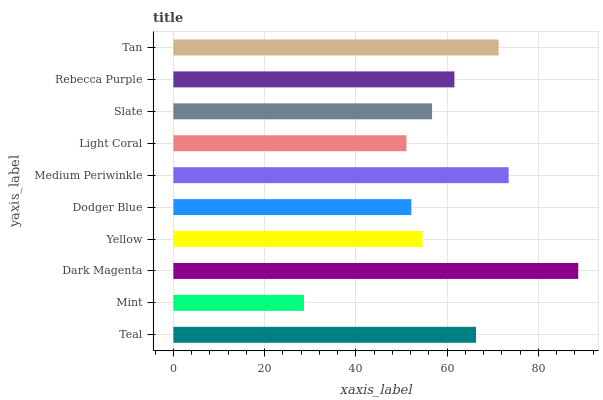Is Mint the minimum?
Answer yes or no. Yes. Is Dark Magenta the maximum?
Answer yes or no. Yes. Is Dark Magenta the minimum?
Answer yes or no. No. Is Mint the maximum?
Answer yes or no. No. Is Dark Magenta greater than Mint?
Answer yes or no. Yes. Is Mint less than Dark Magenta?
Answer yes or no. Yes. Is Mint greater than Dark Magenta?
Answer yes or no. No. Is Dark Magenta less than Mint?
Answer yes or no. No. Is Rebecca Purple the high median?
Answer yes or no. Yes. Is Slate the low median?
Answer yes or no. Yes. Is Dodger Blue the high median?
Answer yes or no. No. Is Light Coral the low median?
Answer yes or no. No. 